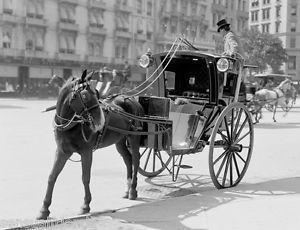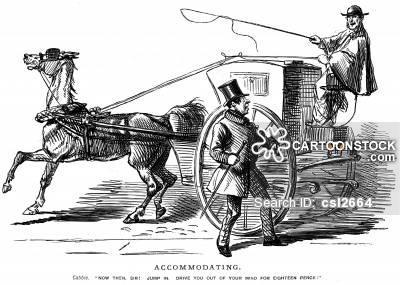The first image is the image on the left, the second image is the image on the right. Analyze the images presented: Is the assertion "One carriage driver is holding a whip." valid? Answer yes or no. Yes. The first image is the image on the left, the second image is the image on the right. Analyze the images presented: Is the assertion "The left and right image contains a total of two horses facing the opposite directions." valid? Answer yes or no. No. 